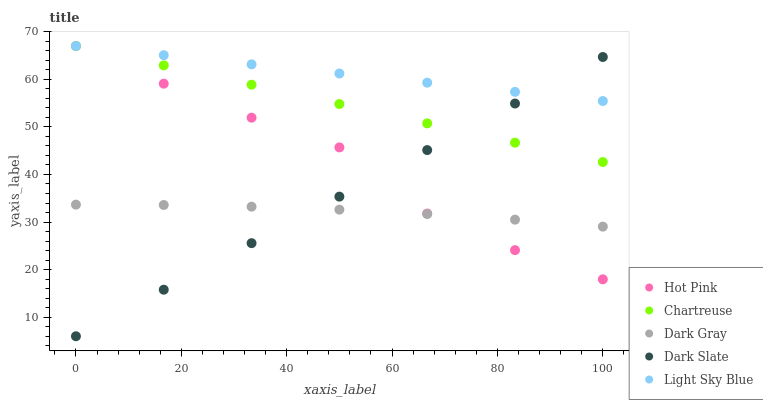Does Dark Gray have the minimum area under the curve?
Answer yes or no. Yes. Does Light Sky Blue have the maximum area under the curve?
Answer yes or no. Yes. Does Dark Slate have the minimum area under the curve?
Answer yes or no. No. Does Dark Slate have the maximum area under the curve?
Answer yes or no. No. Is Chartreuse the smoothest?
Answer yes or no. Yes. Is Hot Pink the roughest?
Answer yes or no. Yes. Is Dark Slate the smoothest?
Answer yes or no. No. Is Dark Slate the roughest?
Answer yes or no. No. Does Dark Slate have the lowest value?
Answer yes or no. Yes. Does Chartreuse have the lowest value?
Answer yes or no. No. Does Light Sky Blue have the highest value?
Answer yes or no. Yes. Does Dark Slate have the highest value?
Answer yes or no. No. Is Dark Gray less than Chartreuse?
Answer yes or no. Yes. Is Light Sky Blue greater than Dark Gray?
Answer yes or no. Yes. Does Hot Pink intersect Light Sky Blue?
Answer yes or no. Yes. Is Hot Pink less than Light Sky Blue?
Answer yes or no. No. Is Hot Pink greater than Light Sky Blue?
Answer yes or no. No. Does Dark Gray intersect Chartreuse?
Answer yes or no. No. 